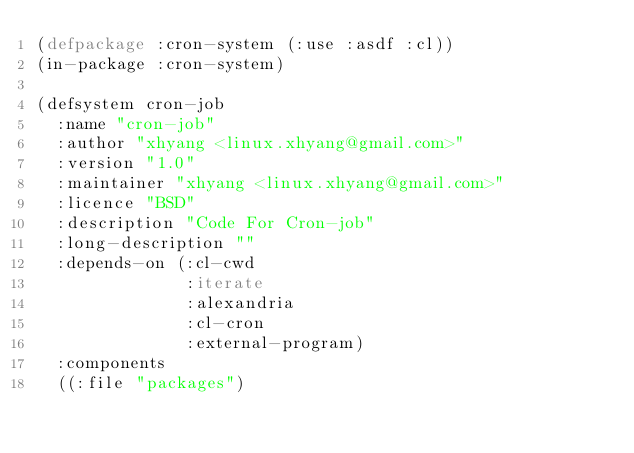Convert code to text. <code><loc_0><loc_0><loc_500><loc_500><_Lisp_>(defpackage :cron-system (:use :asdf :cl))
(in-package :cron-system)

(defsystem cron-job
  :name "cron-job"
  :author "xhyang <linux.xhyang@gmail.com>"
  :version "1.0"
  :maintainer "xhyang <linux.xhyang@gmail.com>"
  :licence "BSD"
  :description "Code For Cron-job"
  :long-description ""
  :depends-on (:cl-cwd
               :iterate
               :alexandria
               :cl-cron
               :external-program)
  :components
  ((:file "packages")</code> 